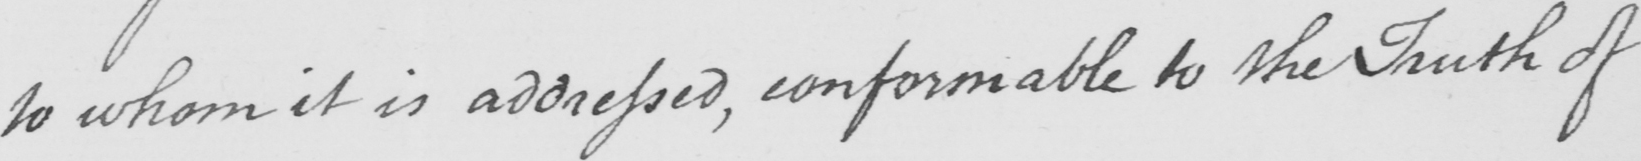Please transcribe the handwritten text in this image. to whom it is addressed , conformable to the Truth of 